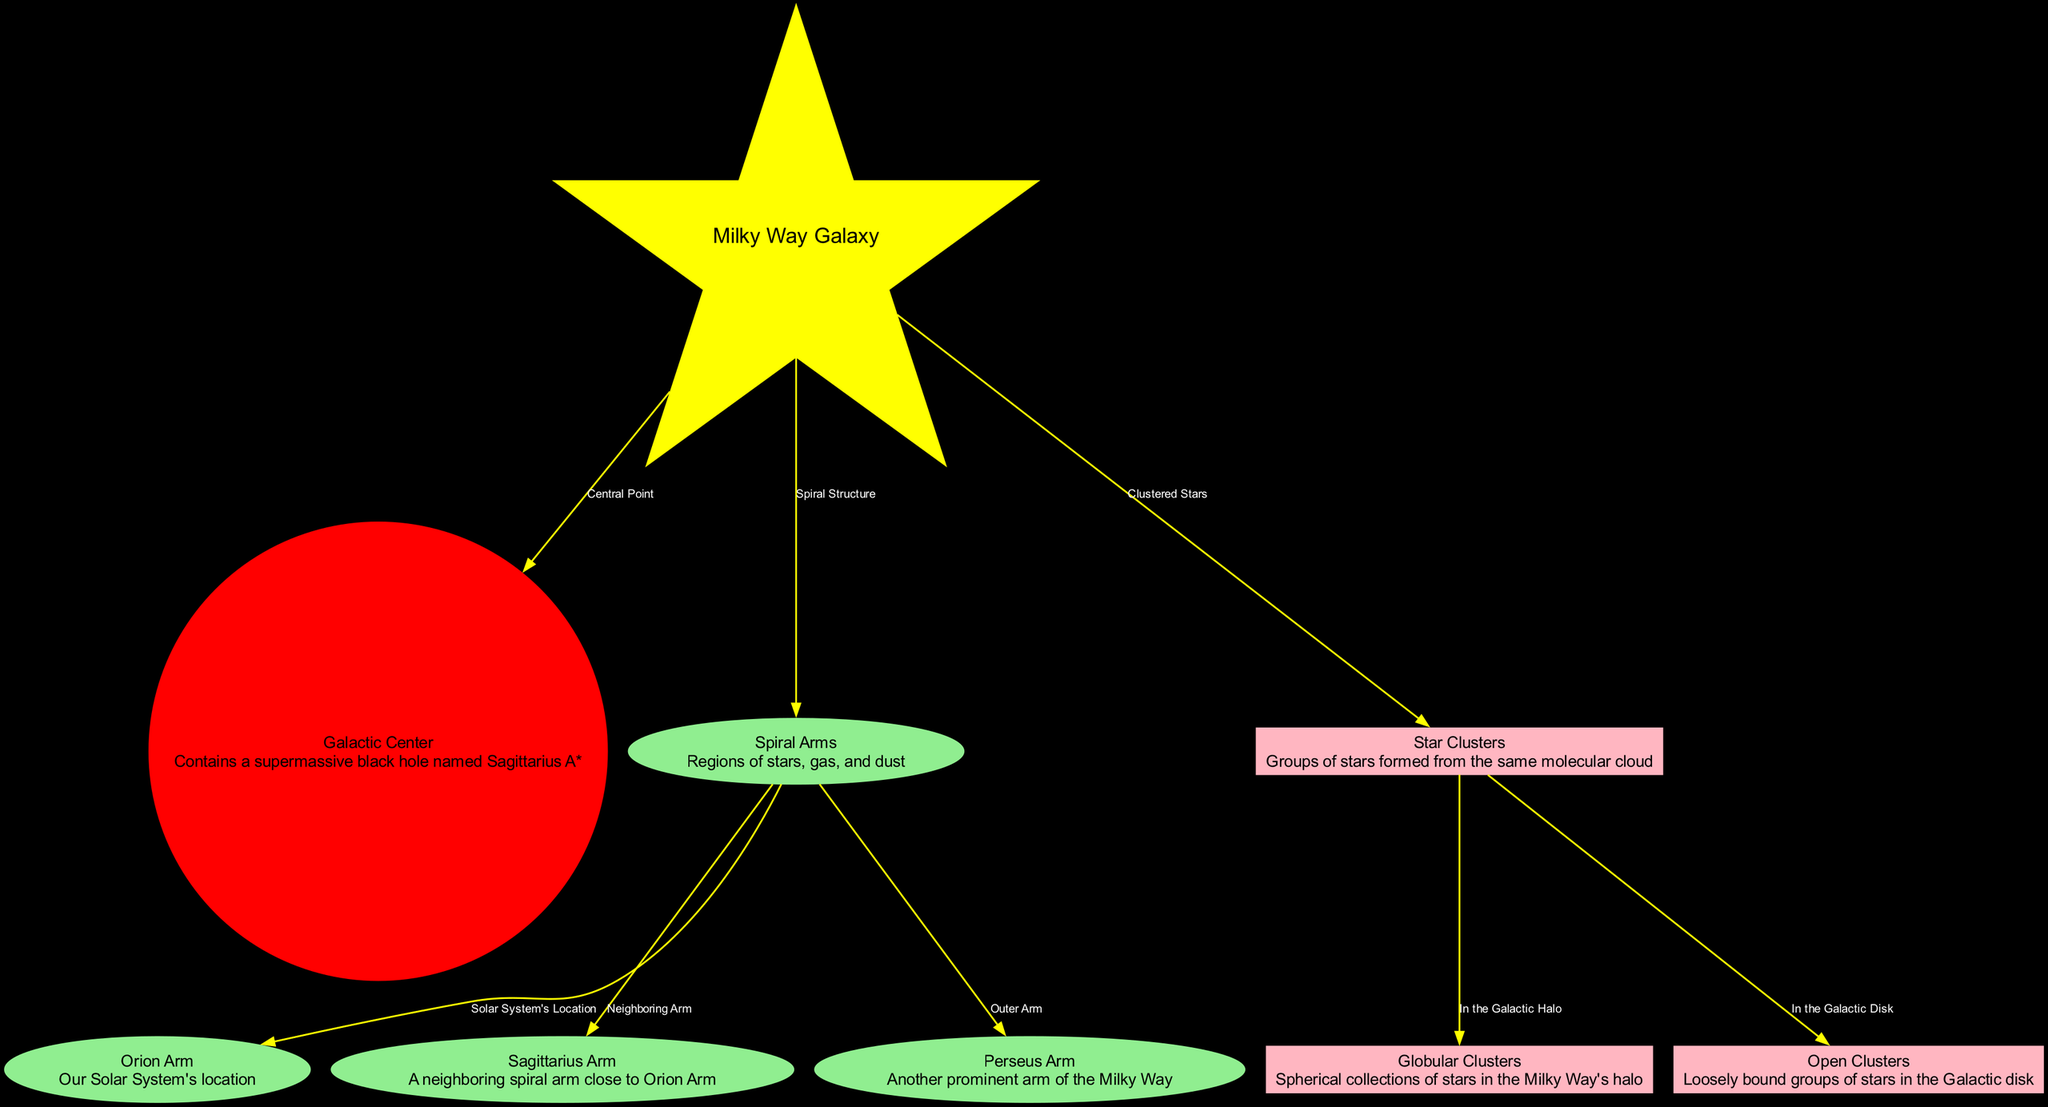What is the central point of the Milky Way Galaxy? The diagram indicates that the central point of the Milky Way Galaxy is the Galactic Center, which contains the supermassive black hole named Sagittarius A*.
Answer: Galactic Center Which region contains our Solar System? The Orion Arm is noted in the diagram as the location of our Solar System, connecting to the Spiral Arms as well.
Answer: Orion Arm How many spiral arms are mentioned in the diagram? The diagram identifies three spiral arms: Orion Arm, Sagittarius Arm, and Perseus Arm, resulting in a total count of three.
Answer: 3 In which region are star clusters located? The diagram links Star Clusters directly to the Milky Way, indicating they are clustered stars formed from the same molecular cloud in the Galactic structure.
Answer: Milky Way Which type of clusters are loosely bound groups of stars? Open Clusters are categorized as loosely bound groups of stars specifically located in the Galactic disk.
Answer: Open Clusters What connects the Star Clusters to the Globular Clusters? The diagram shows that Star Clusters are part of the Galactic Halo and connect to Globular Clusters through the relationship indicated in the edges of the diagram.
Answer: In the Galactic Halo Which arm is identified as a neighboring arm to the Orion Arm? The Sagittarius Arm is described as a neighboring spiral arm that is close to the Orion Arm in the structure of the Milky Way.
Answer: Sagittarius Arm What shape is the Milky Way Galaxy node? The Milky Way Galaxy is represented by a star shape in the diagram, contrasting with the other node shapes.
Answer: Star What color represents the Galactic Center in the diagram? The Galactic Center is colored red in the diagram, signifying its role and central presence in the Milky Way structure.
Answer: Red 